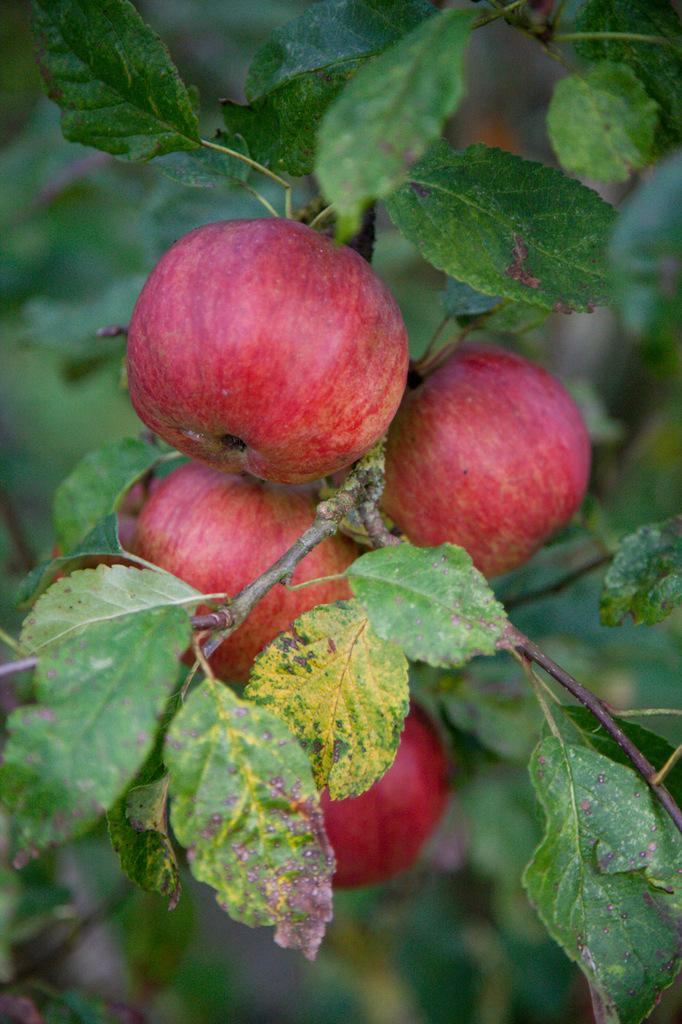What type of living organism can be seen in the image? There is a plant in the image. What is the plant producing? The plant has fruits. What color are the fruits on the plant? The fruits are red in color. What else is part of the plant besides the fruits? The plant has leaves. How are the leaves connected to the rest of the plant? The leaves are attached to the stem. How many apples are in the crate next to the plant? There is no crate or apples present in the image; it only features a plant with red fruits and leaves. 